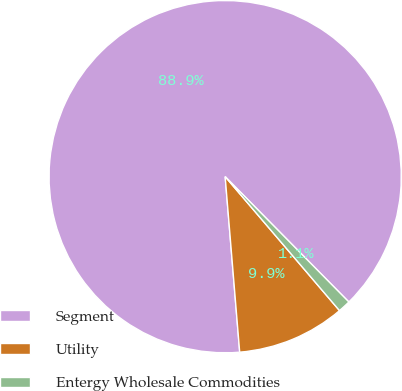Convert chart to OTSL. <chart><loc_0><loc_0><loc_500><loc_500><pie_chart><fcel>Segment<fcel>Utility<fcel>Entergy Wholesale Commodities<nl><fcel>88.92%<fcel>9.93%<fcel>1.15%<nl></chart> 